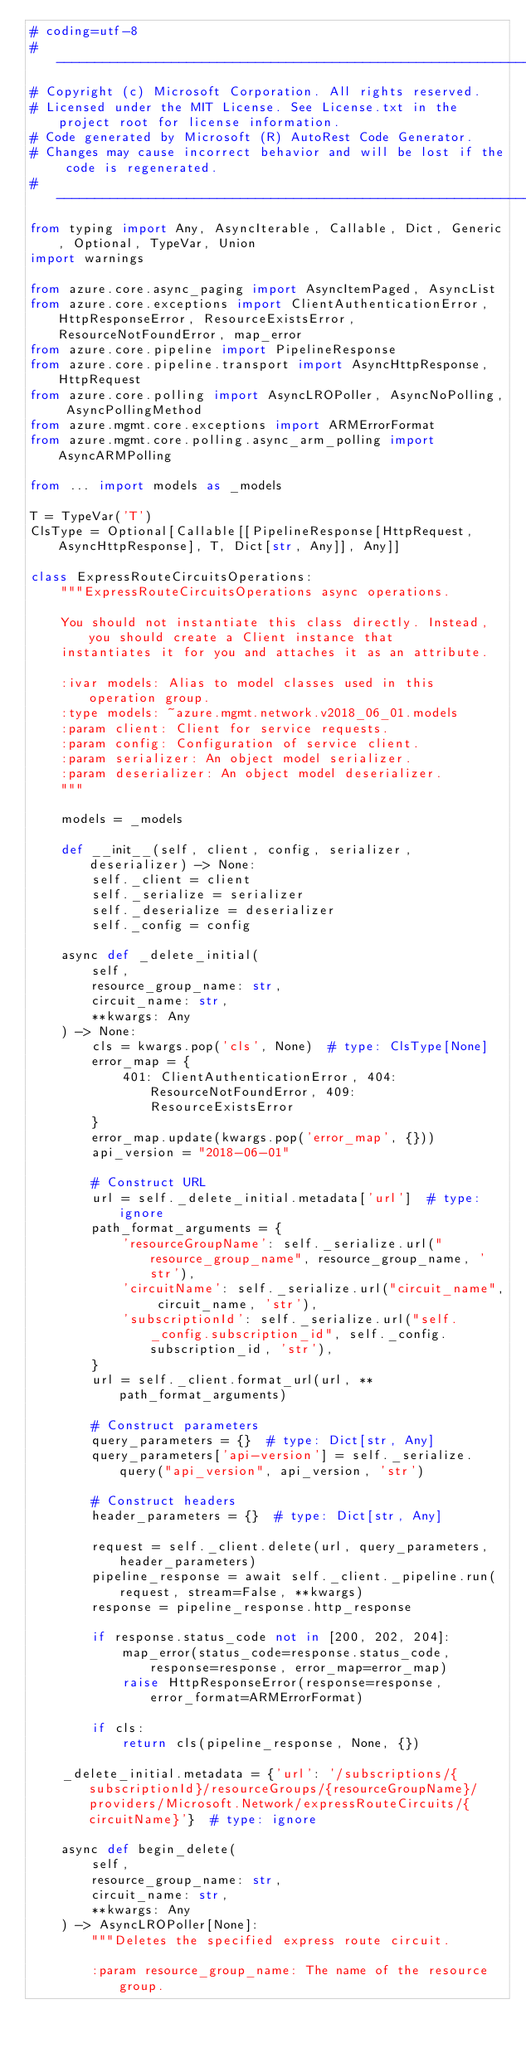Convert code to text. <code><loc_0><loc_0><loc_500><loc_500><_Python_># coding=utf-8
# --------------------------------------------------------------------------
# Copyright (c) Microsoft Corporation. All rights reserved.
# Licensed under the MIT License. See License.txt in the project root for license information.
# Code generated by Microsoft (R) AutoRest Code Generator.
# Changes may cause incorrect behavior and will be lost if the code is regenerated.
# --------------------------------------------------------------------------
from typing import Any, AsyncIterable, Callable, Dict, Generic, Optional, TypeVar, Union
import warnings

from azure.core.async_paging import AsyncItemPaged, AsyncList
from azure.core.exceptions import ClientAuthenticationError, HttpResponseError, ResourceExistsError, ResourceNotFoundError, map_error
from azure.core.pipeline import PipelineResponse
from azure.core.pipeline.transport import AsyncHttpResponse, HttpRequest
from azure.core.polling import AsyncLROPoller, AsyncNoPolling, AsyncPollingMethod
from azure.mgmt.core.exceptions import ARMErrorFormat
from azure.mgmt.core.polling.async_arm_polling import AsyncARMPolling

from ... import models as _models

T = TypeVar('T')
ClsType = Optional[Callable[[PipelineResponse[HttpRequest, AsyncHttpResponse], T, Dict[str, Any]], Any]]

class ExpressRouteCircuitsOperations:
    """ExpressRouteCircuitsOperations async operations.

    You should not instantiate this class directly. Instead, you should create a Client instance that
    instantiates it for you and attaches it as an attribute.

    :ivar models: Alias to model classes used in this operation group.
    :type models: ~azure.mgmt.network.v2018_06_01.models
    :param client: Client for service requests.
    :param config: Configuration of service client.
    :param serializer: An object model serializer.
    :param deserializer: An object model deserializer.
    """

    models = _models

    def __init__(self, client, config, serializer, deserializer) -> None:
        self._client = client
        self._serialize = serializer
        self._deserialize = deserializer
        self._config = config

    async def _delete_initial(
        self,
        resource_group_name: str,
        circuit_name: str,
        **kwargs: Any
    ) -> None:
        cls = kwargs.pop('cls', None)  # type: ClsType[None]
        error_map = {
            401: ClientAuthenticationError, 404: ResourceNotFoundError, 409: ResourceExistsError
        }
        error_map.update(kwargs.pop('error_map', {}))
        api_version = "2018-06-01"

        # Construct URL
        url = self._delete_initial.metadata['url']  # type: ignore
        path_format_arguments = {
            'resourceGroupName': self._serialize.url("resource_group_name", resource_group_name, 'str'),
            'circuitName': self._serialize.url("circuit_name", circuit_name, 'str'),
            'subscriptionId': self._serialize.url("self._config.subscription_id", self._config.subscription_id, 'str'),
        }
        url = self._client.format_url(url, **path_format_arguments)

        # Construct parameters
        query_parameters = {}  # type: Dict[str, Any]
        query_parameters['api-version'] = self._serialize.query("api_version", api_version, 'str')

        # Construct headers
        header_parameters = {}  # type: Dict[str, Any]

        request = self._client.delete(url, query_parameters, header_parameters)
        pipeline_response = await self._client._pipeline.run(request, stream=False, **kwargs)
        response = pipeline_response.http_response

        if response.status_code not in [200, 202, 204]:
            map_error(status_code=response.status_code, response=response, error_map=error_map)
            raise HttpResponseError(response=response, error_format=ARMErrorFormat)

        if cls:
            return cls(pipeline_response, None, {})

    _delete_initial.metadata = {'url': '/subscriptions/{subscriptionId}/resourceGroups/{resourceGroupName}/providers/Microsoft.Network/expressRouteCircuits/{circuitName}'}  # type: ignore

    async def begin_delete(
        self,
        resource_group_name: str,
        circuit_name: str,
        **kwargs: Any
    ) -> AsyncLROPoller[None]:
        """Deletes the specified express route circuit.

        :param resource_group_name: The name of the resource group.</code> 